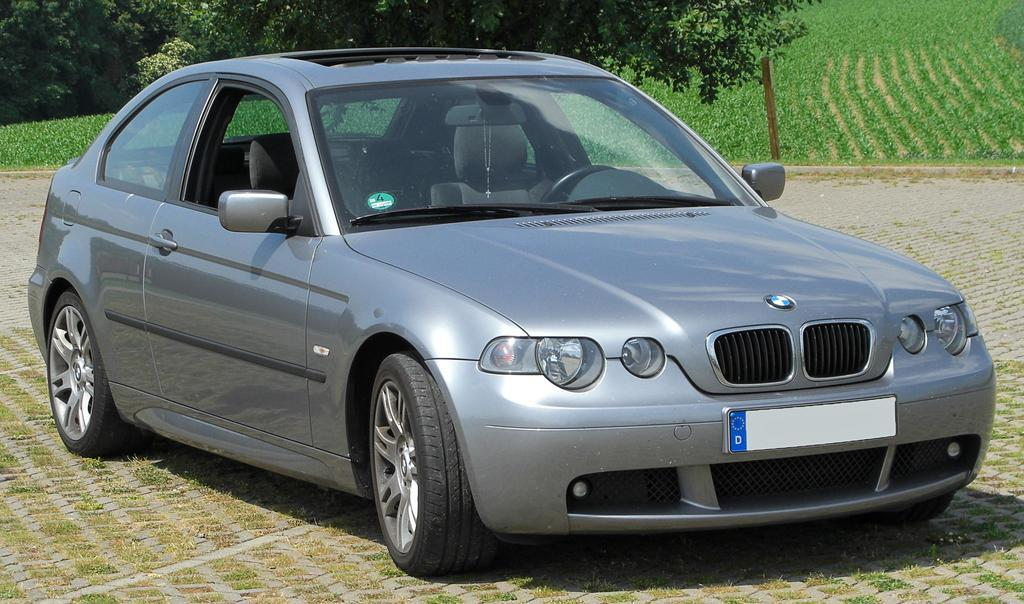What is the main subject of the image? The main subject of the image is a car. Where is the car located in the image? The car is on the ground in the image. What can be seen in the background of the image? There is a field and trees in the background of the image. What type of holiday decoration is hanging from the car in the image? There are no holiday decorations present in the image; it only features a car on the ground with a field and trees in the background. 